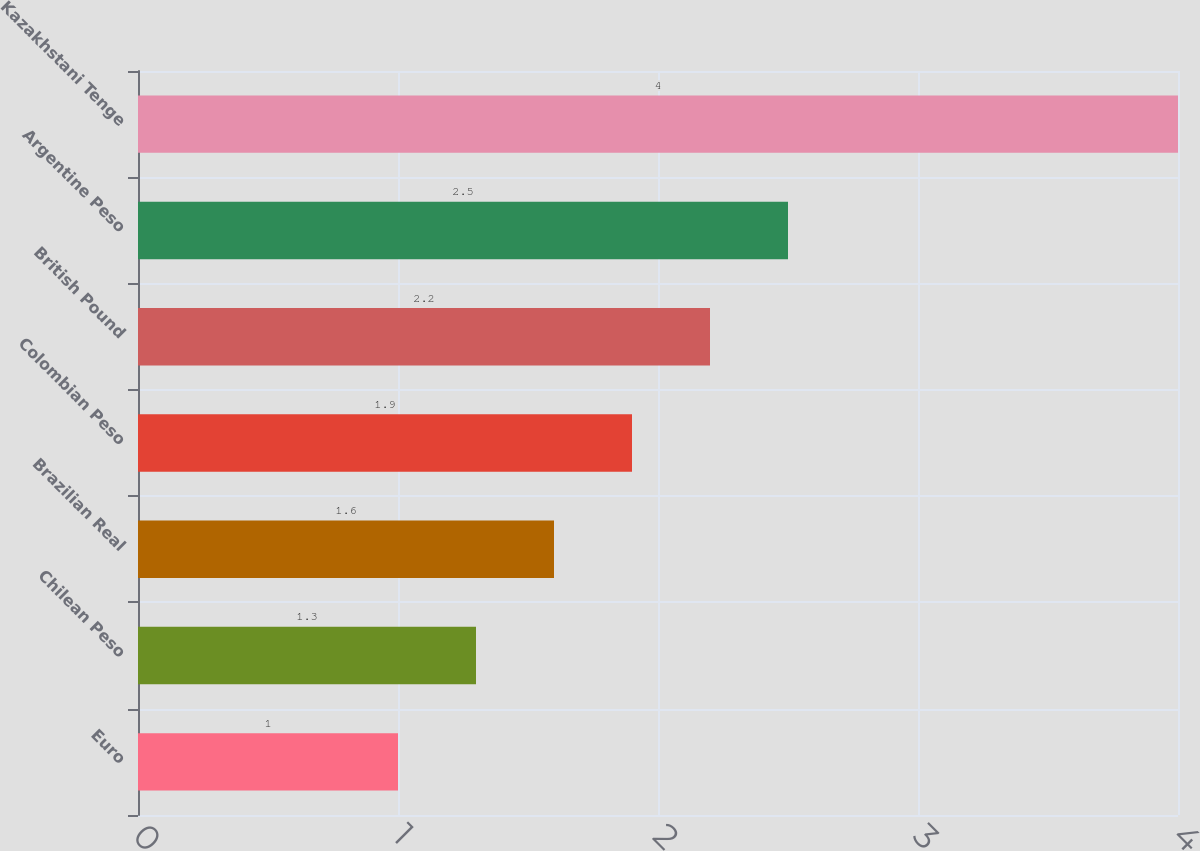Convert chart to OTSL. <chart><loc_0><loc_0><loc_500><loc_500><bar_chart><fcel>Euro<fcel>Chilean Peso<fcel>Brazilian Real<fcel>Colombian Peso<fcel>British Pound<fcel>Argentine Peso<fcel>Kazakhstani Tenge<nl><fcel>1<fcel>1.3<fcel>1.6<fcel>1.9<fcel>2.2<fcel>2.5<fcel>4<nl></chart> 